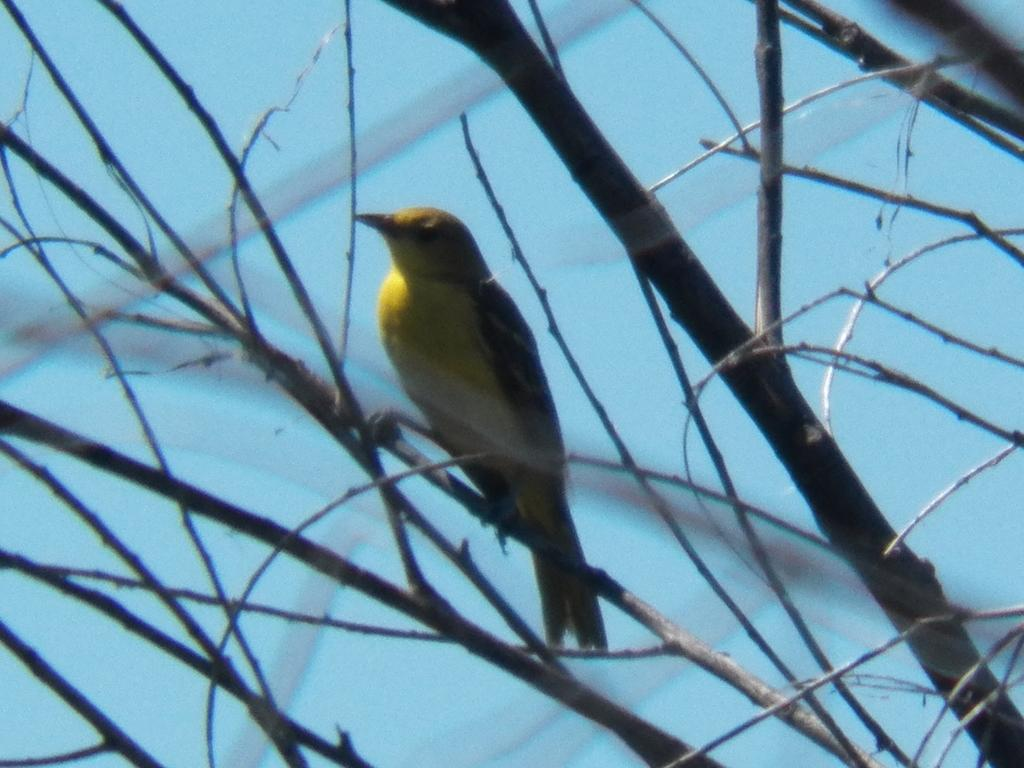What type of animal can be seen in the image? There is a bird in the image. Where is the bird located in the image? The bird is sitting on the branches of a tree. How many pies are being copied for the birthday party in the image? There is no mention of pies or a birthday party in the image; it only features a bird sitting on the branches of a tree. 